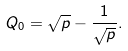Convert formula to latex. <formula><loc_0><loc_0><loc_500><loc_500>Q _ { 0 } = \sqrt { p } - \frac { 1 } { \sqrt { p } } .</formula> 